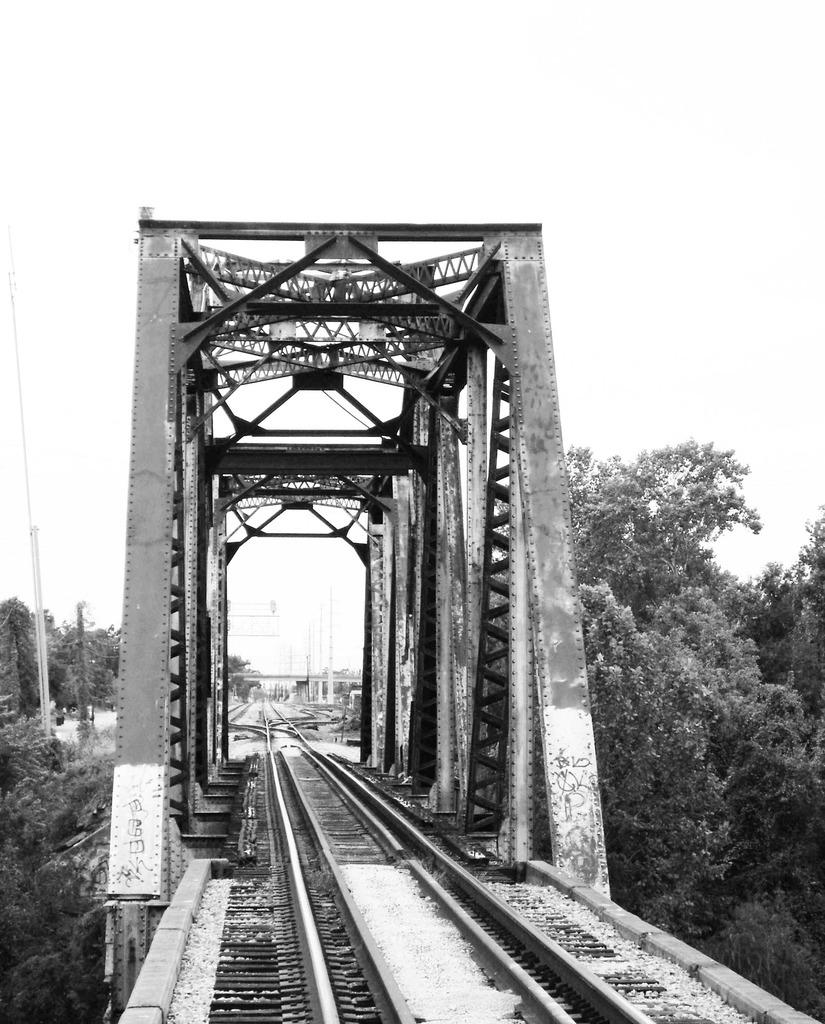What type of bridge is in the center of the image? There is a truss bridge in the center of the image. What is on the bridge? The bridge has a railway track on it. What can be seen in the background of the image? There is sky and trees visible in the background of the image. Are there any other objects in the background? Yes, there are some unspecified objects in the background of the image. Can you see a cat performing on the stage in the background of the image? There is no cat or stage present in the image. 